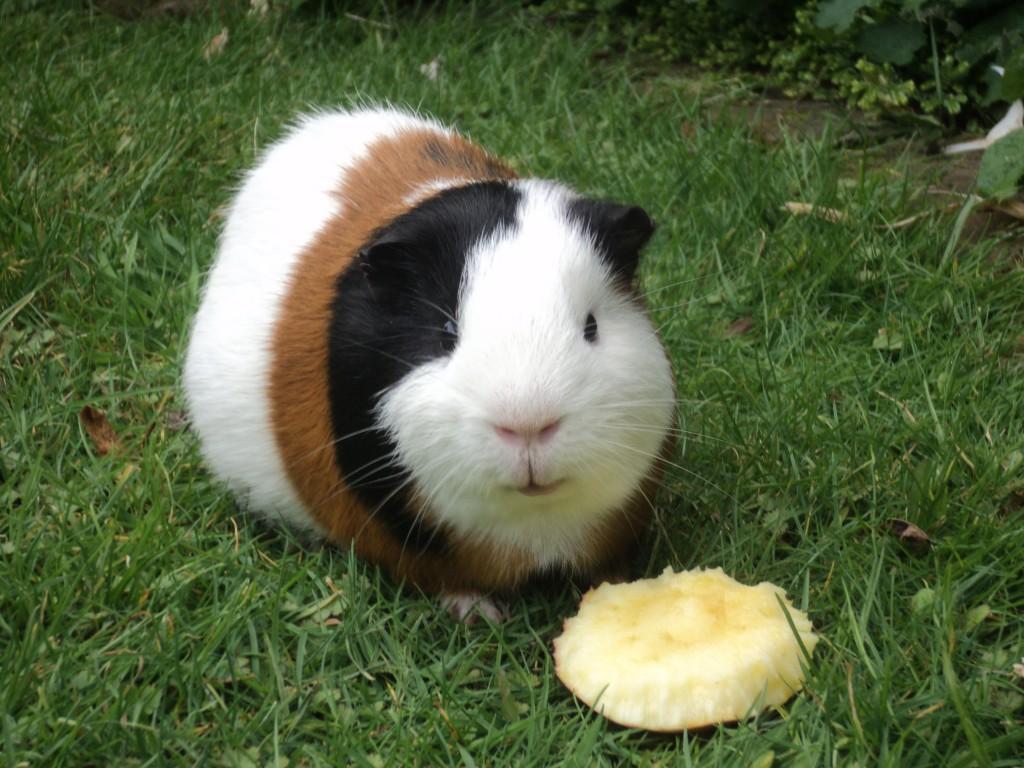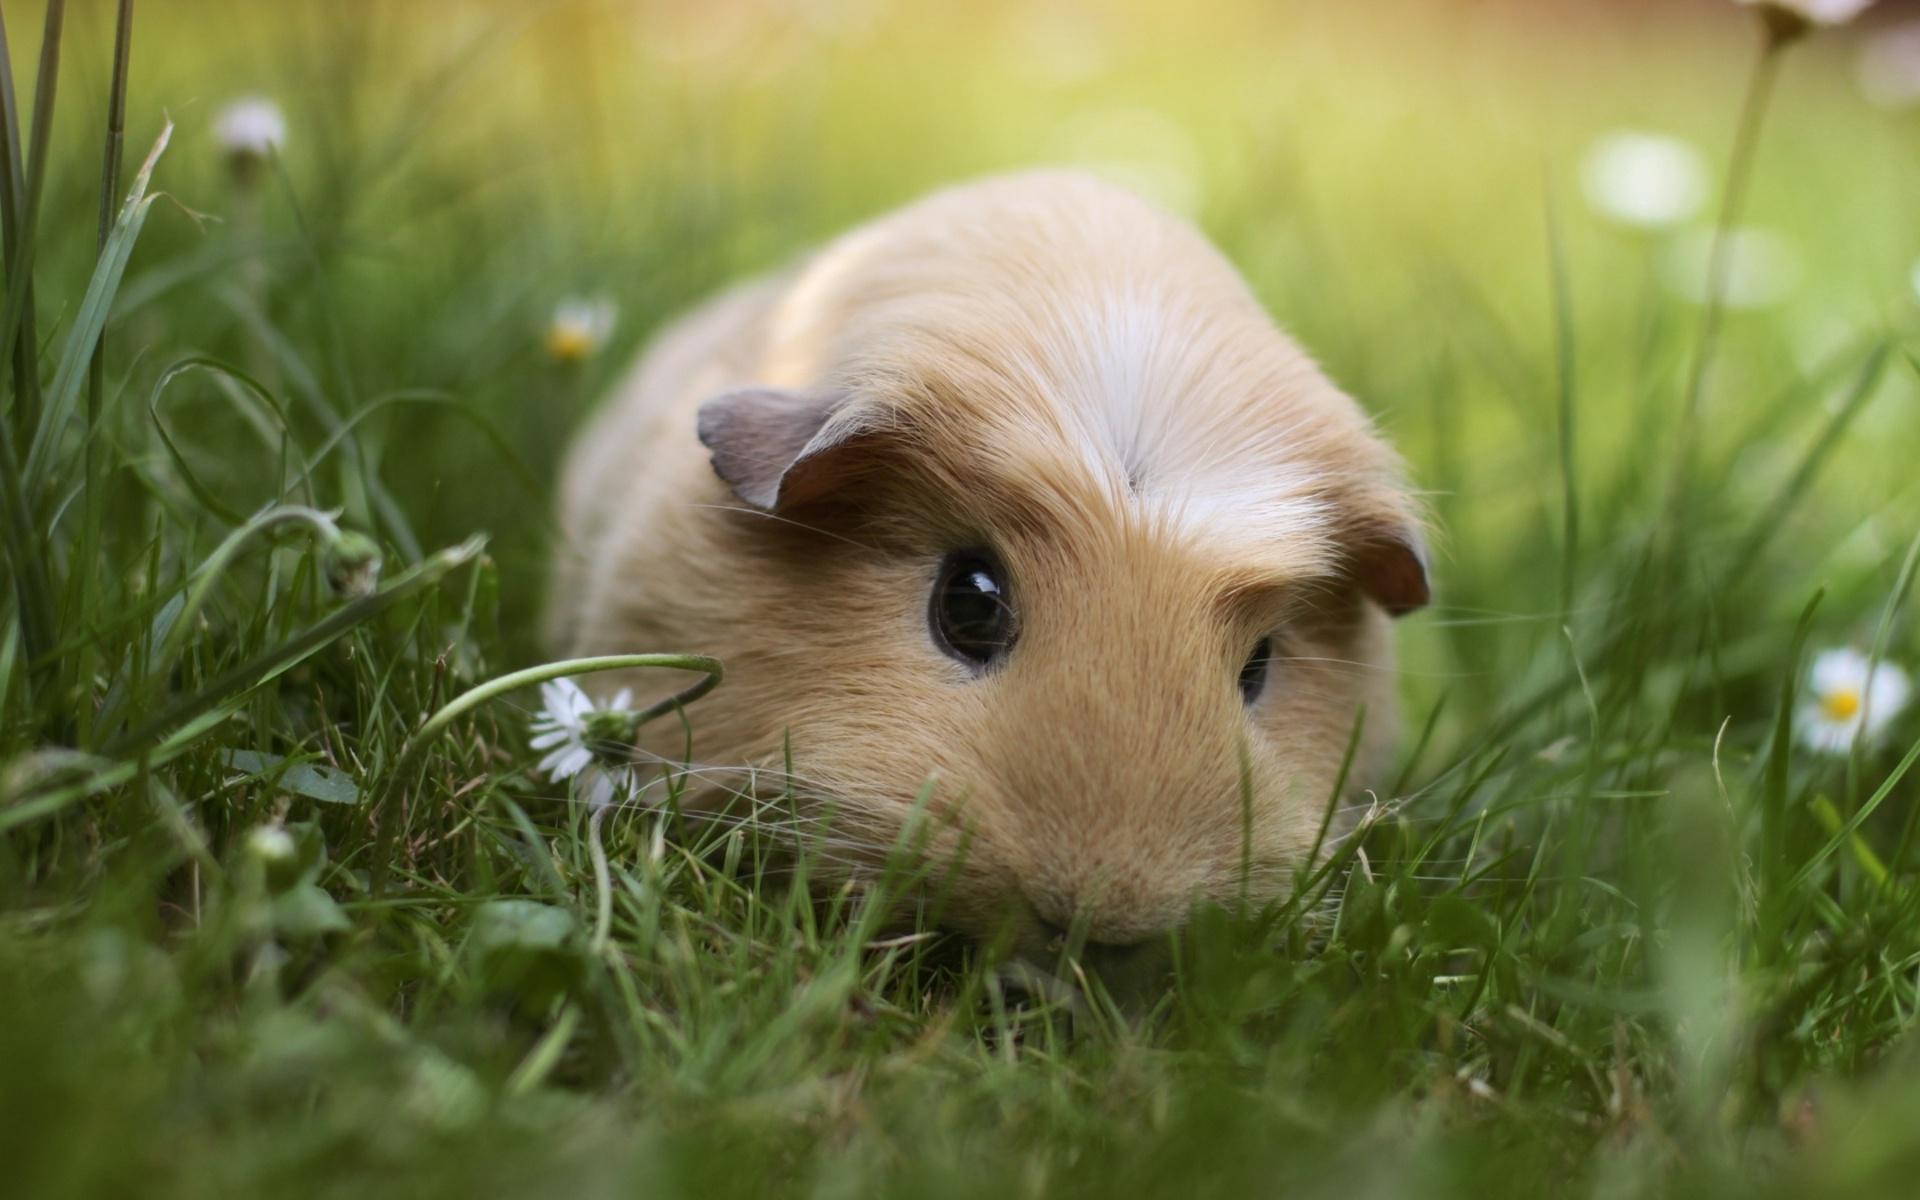The first image is the image on the left, the second image is the image on the right. For the images shown, is this caption "At least one guinea pig has a brown face with a white stripe." true? Answer yes or no. No. 